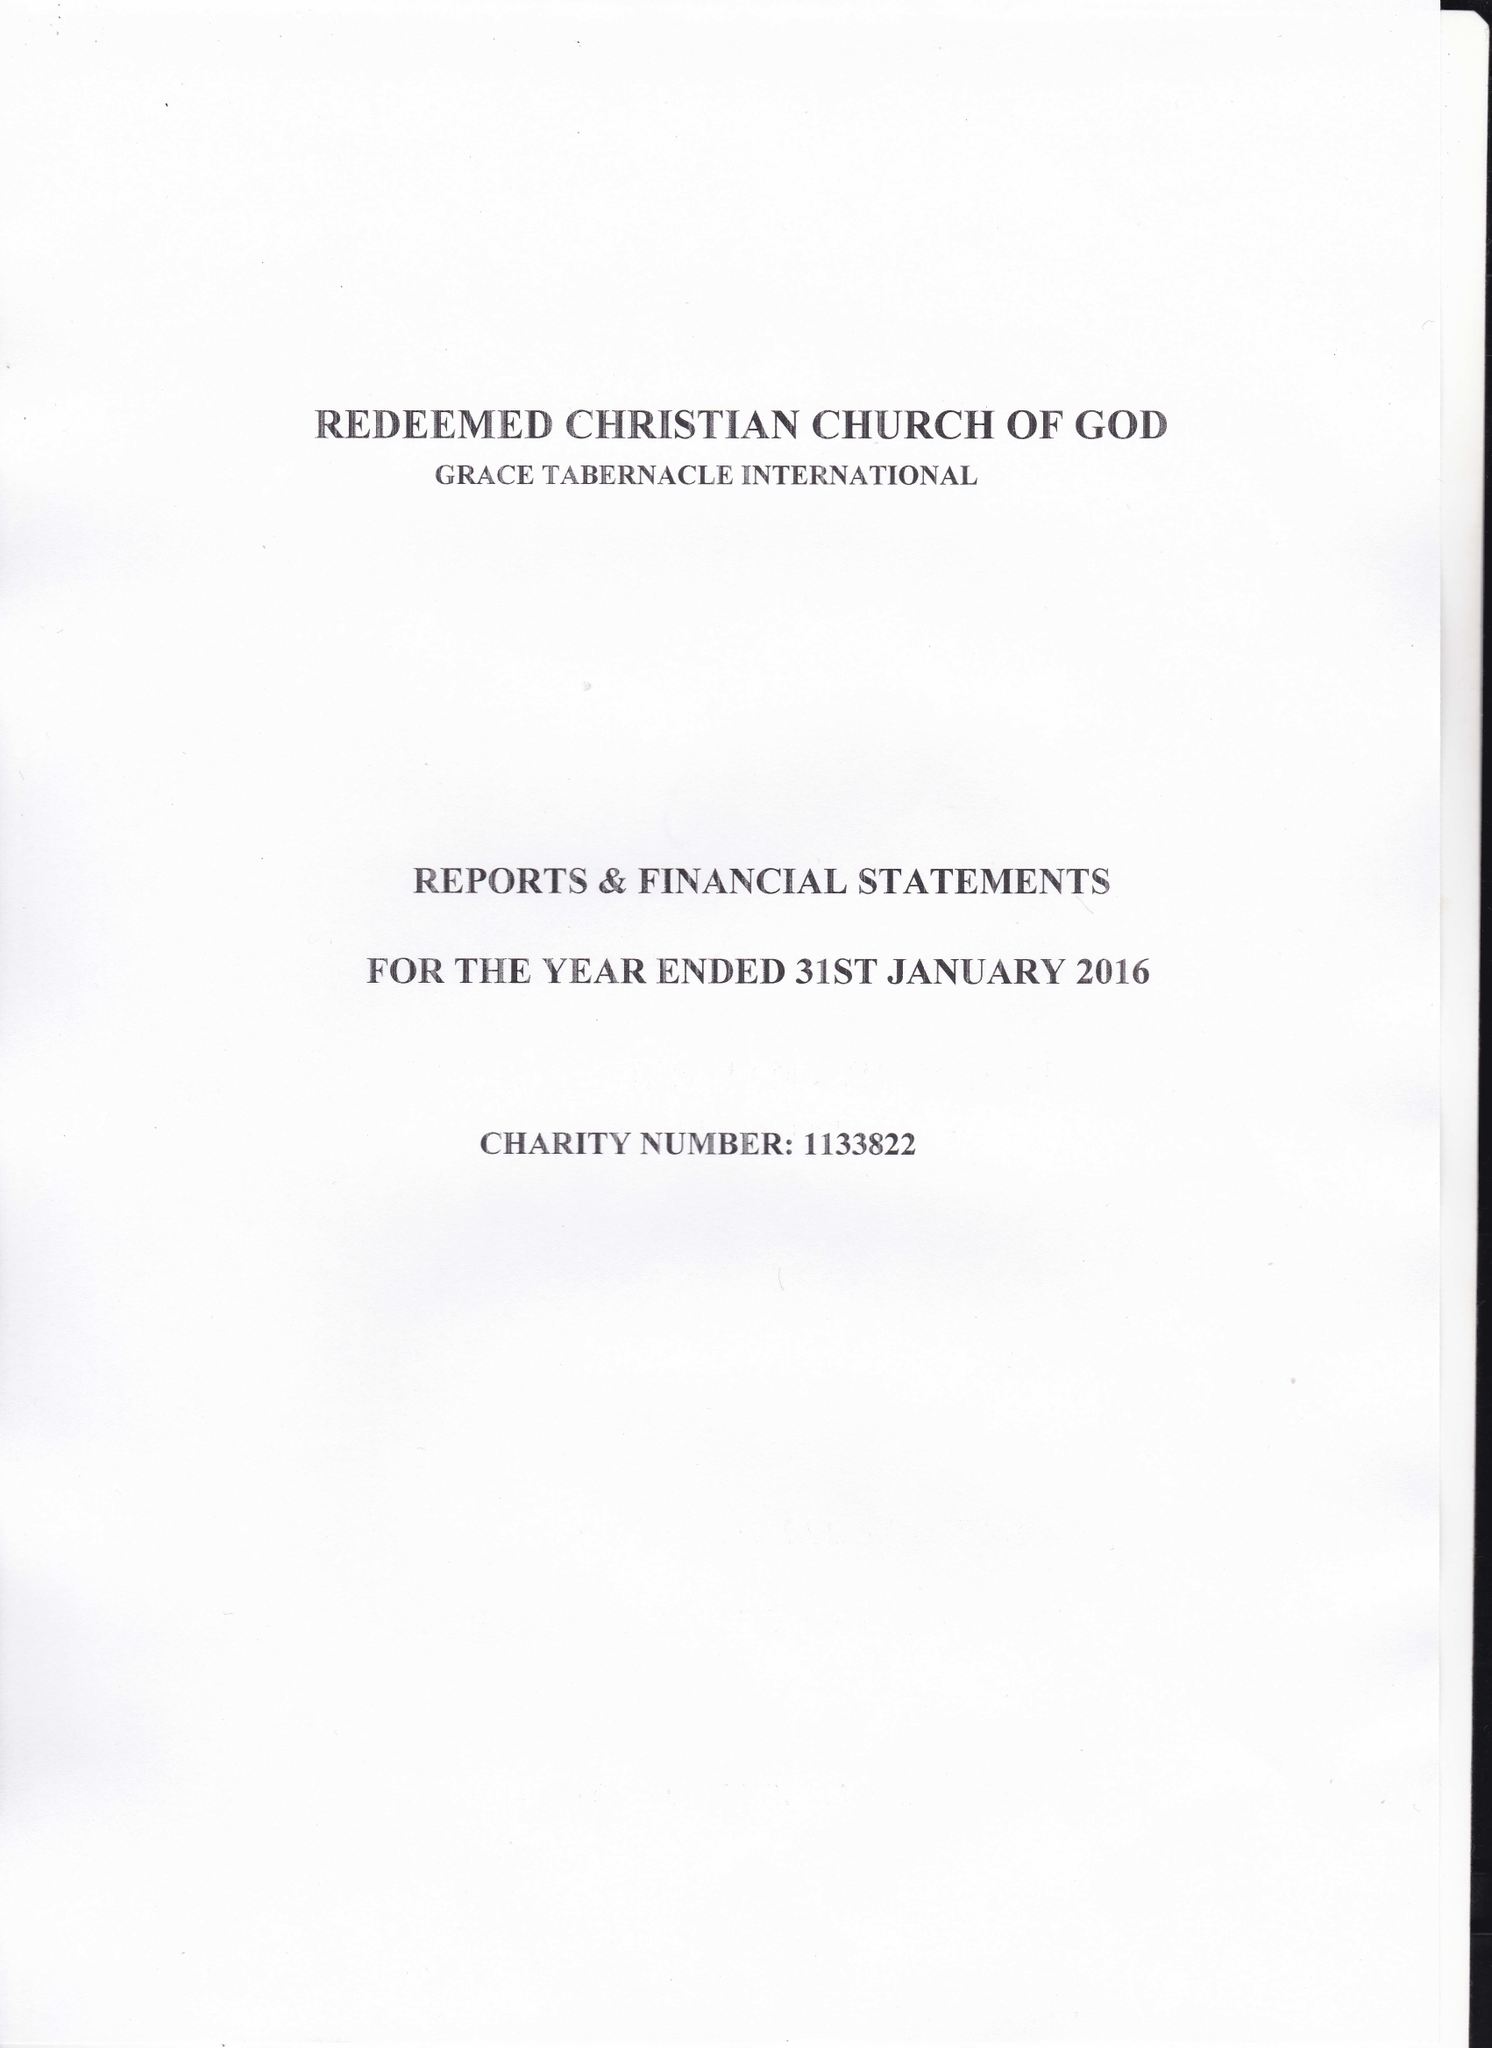What is the value for the charity_name?
Answer the question using a single word or phrase. Redeemed Christian Church Of God -Grace Tabernacle International 